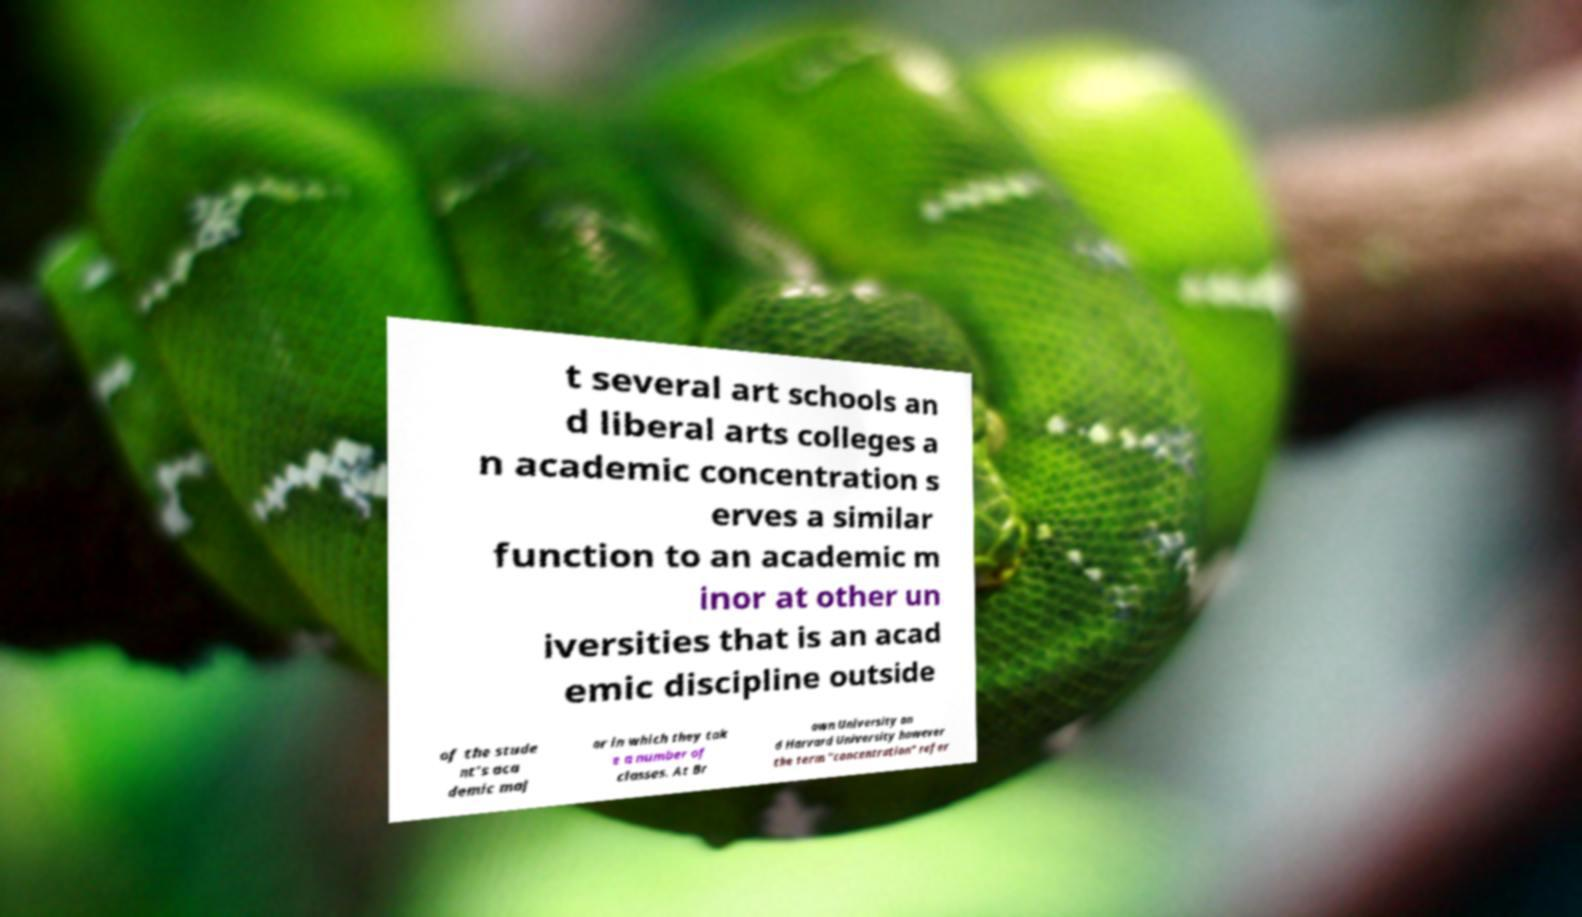Can you accurately transcribe the text from the provided image for me? t several art schools an d liberal arts colleges a n academic concentration s erves a similar function to an academic m inor at other un iversities that is an acad emic discipline outside of the stude nt's aca demic maj or in which they tak e a number of classes. At Br own University an d Harvard University however the term "concentration" refer 